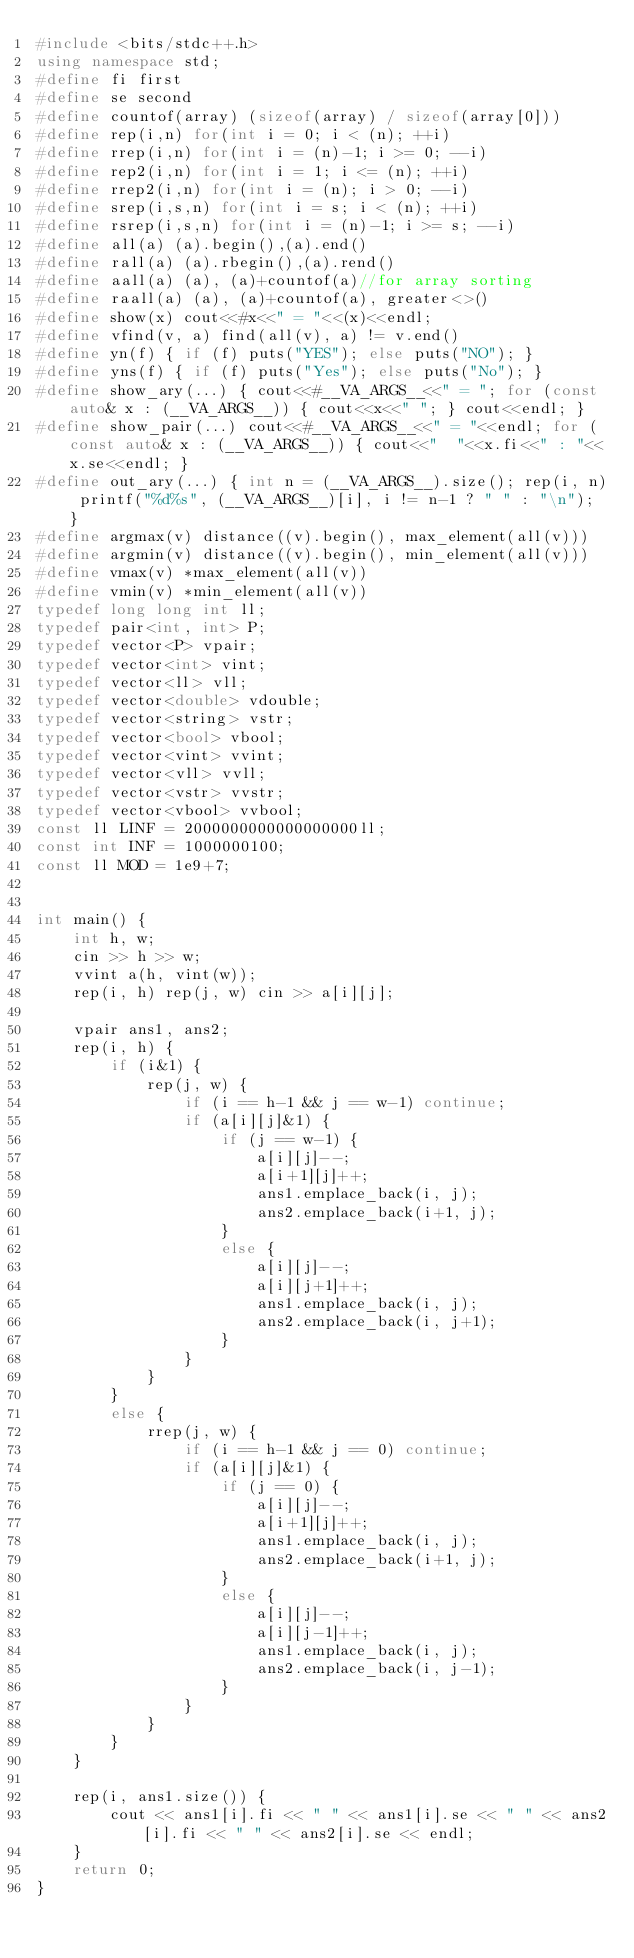Convert code to text. <code><loc_0><loc_0><loc_500><loc_500><_C++_>#include <bits/stdc++.h>
using namespace std;
#define fi first
#define se second
#define countof(array) (sizeof(array) / sizeof(array[0]))
#define rep(i,n) for(int i = 0; i < (n); ++i)
#define rrep(i,n) for(int i = (n)-1; i >= 0; --i)
#define rep2(i,n) for(int i = 1; i <= (n); ++i)
#define rrep2(i,n) for(int i = (n); i > 0; --i)
#define srep(i,s,n) for(int i = s; i < (n); ++i)
#define rsrep(i,s,n) for(int i = (n)-1; i >= s; --i)
#define all(a) (a).begin(),(a).end()
#define rall(a) (a).rbegin(),(a).rend()
#define aall(a) (a), (a)+countof(a)//for array sorting
#define raall(a) (a), (a)+countof(a), greater<>()
#define show(x) cout<<#x<<" = "<<(x)<<endl;
#define vfind(v, a) find(all(v), a) != v.end()
#define yn(f) { if (f) puts("YES"); else puts("NO"); }
#define yns(f) { if (f) puts("Yes"); else puts("No"); }
#define show_ary(...) { cout<<#__VA_ARGS__<<" = "; for (const auto& x : (__VA_ARGS__)) { cout<<x<<" "; } cout<<endl; }
#define show_pair(...) cout<<#__VA_ARGS__<<" = "<<endl; for (const auto& x : (__VA_ARGS__)) { cout<<"  "<<x.fi<<" : "<<x.se<<endl; }
#define out_ary(...) { int n = (__VA_ARGS__).size(); rep(i, n) printf("%d%s", (__VA_ARGS__)[i], i != n-1 ? " " : "\n"); }
#define argmax(v) distance((v).begin(), max_element(all(v)))
#define argmin(v) distance((v).begin(), min_element(all(v)))
#define vmax(v) *max_element(all(v))
#define vmin(v) *min_element(all(v))
typedef long long int ll;
typedef pair<int, int> P;
typedef vector<P> vpair;
typedef vector<int> vint;
typedef vector<ll> vll;
typedef vector<double> vdouble;
typedef vector<string> vstr;
typedef vector<bool> vbool;
typedef vector<vint> vvint;
typedef vector<vll> vvll;
typedef vector<vstr> vvstr;
typedef vector<vbool> vvbool;
const ll LINF = 2000000000000000000ll;
const int INF = 1000000100;
const ll MOD = 1e9+7;


int main() {
    int h, w;
    cin >> h >> w;
    vvint a(h, vint(w));
    rep(i, h) rep(j, w) cin >> a[i][j];

    vpair ans1, ans2;
    rep(i, h) {
        if (i&1) {
            rep(j, w) {
                if (i == h-1 && j == w-1) continue;
                if (a[i][j]&1) {
                    if (j == w-1) {
                        a[i][j]--;
                        a[i+1][j]++;
                        ans1.emplace_back(i, j);
                        ans2.emplace_back(i+1, j);
                    }
                    else {
                        a[i][j]--;
                        a[i][j+1]++;
                        ans1.emplace_back(i, j);
                        ans2.emplace_back(i, j+1);
                    }
                }
            }
        }
        else {
            rrep(j, w) {
                if (i == h-1 && j == 0) continue;
                if (a[i][j]&1) {
                    if (j == 0) {
                        a[i][j]--;
                        a[i+1][j]++;
                        ans1.emplace_back(i, j);
                        ans2.emplace_back(i+1, j);
                    }
                    else {
                        a[i][j]--;
                        a[i][j-1]++;
                        ans1.emplace_back(i, j);
                        ans2.emplace_back(i, j-1);
                    }
                }
            }
        }
    }

    rep(i, ans1.size()) {
        cout << ans1[i].fi << " " << ans1[i].se << " " << ans2[i].fi << " " << ans2[i].se << endl;
    }
    return 0;
}</code> 